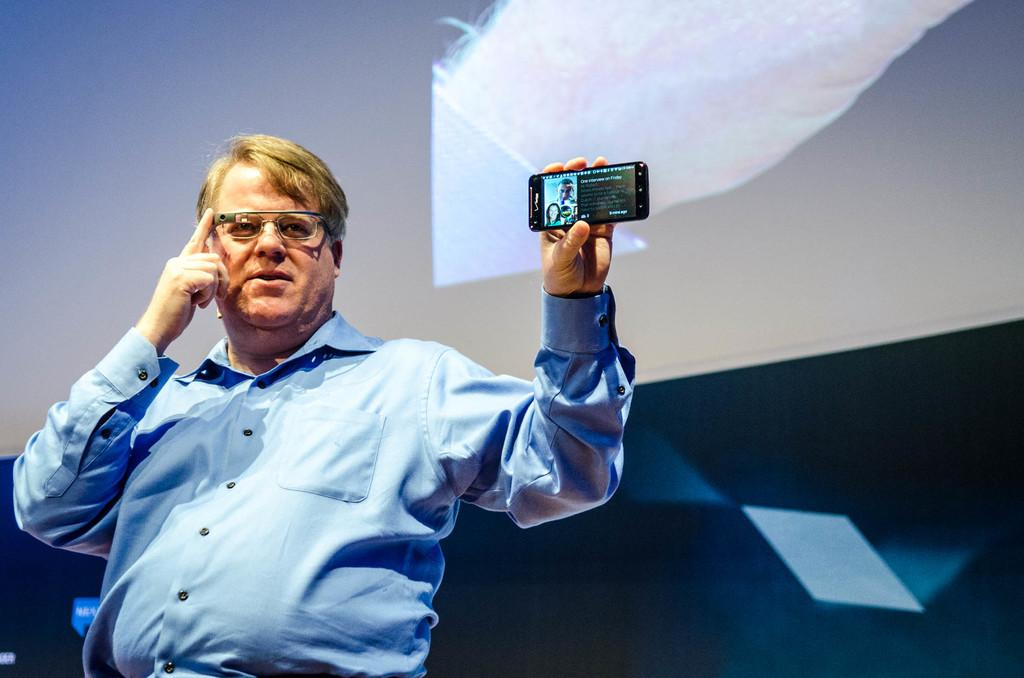Who is the main subject in the image? There is a man in the image. Where is the man located in the image? The man is standing on a stage. What is the man holding in his hand? The man is holding a mobile phone in his hand. What type of feeling does the man have while standing on the stage? There is no indication of the man's feelings in the image, so it cannot be determined from the image alone. 